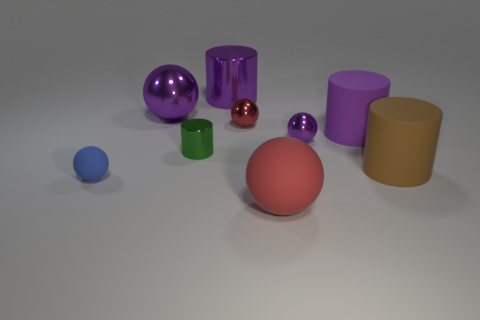There is a big rubber thing that is in front of the big rubber cylinder right of the purple thing on the right side of the small purple ball; what shape is it?
Keep it short and to the point. Sphere. What is the shape of the matte object that is both in front of the large brown object and right of the large metal cylinder?
Provide a short and direct response. Sphere. There is a metal ball to the left of the big shiny object behind the large purple metal ball; how many purple rubber cylinders are behind it?
Your answer should be very brief. 0. The red metallic thing that is the same shape as the blue thing is what size?
Provide a succinct answer. Small. Does the big sphere that is behind the big brown matte cylinder have the same material as the small purple object?
Make the answer very short. Yes. What color is the big rubber object that is the same shape as the tiny blue rubber object?
Provide a short and direct response. Red. What number of other things are there of the same color as the big metallic cylinder?
Give a very brief answer. 3. Does the metal object that is to the left of the small green metallic object have the same shape as the rubber thing on the left side of the small green cylinder?
Keep it short and to the point. Yes. What number of cubes are either large brown objects or rubber things?
Your answer should be very brief. 0. Is the number of small blue objects behind the large brown cylinder less than the number of red shiny spheres?
Give a very brief answer. Yes. 